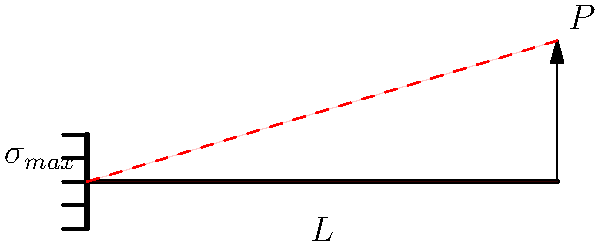In a surprise twist, an indie artist decides to perform on a cantilever stage extension. The performance setup can be modeled as a cantilever beam with length $L$ and a point load $P$ at the free end. If the beam has a rectangular cross-section with width $b$ and height $h$, what is the maximum bending stress $\sigma_{max}$ in terms of $P$, $L$, $b$, and $h$? Let's approach this step-by-step:

1) For a cantilever beam with a point load at the free end, the maximum bending moment $M_{max}$ occurs at the fixed end and is given by:

   $M_{max} = PL$

2) The bending stress distribution in a beam is given by the flexure formula:

   $\sigma = \frac{My}{I}$

   Where $M$ is the bending moment, $y$ is the distance from the neutral axis, and $I$ is the moment of inertia of the cross-section.

3) The maximum stress occurs at the outermost fibers, where $y = h/2$

4) For a rectangular cross-section, the moment of inertia $I$ is:

   $I = \frac{bh^3}{12}$

5) Substituting these into the flexure formula:

   $\sigma_{max} = \frac{M_{max}(h/2)}{I} = \frac{PL(h/2)}{\frac{bh^3}{12}}$

6) Simplifying:

   $\sigma_{max} = \frac{6PL}{bh^2}$

This formula gives the maximum bending stress in the cantilever beam.
Answer: $\sigma_{max} = \frac{6PL}{bh^2}$ 